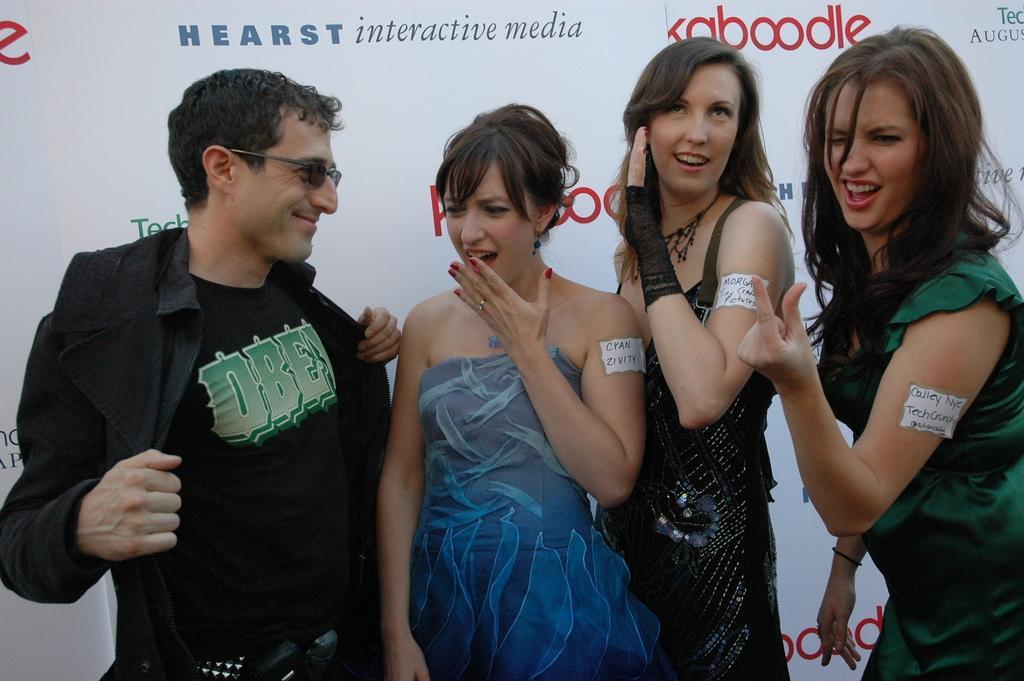How would you summarize this image in a sentence or two? In this picture we can see a man and three women standing and smiling and in the background we can see a banner. 